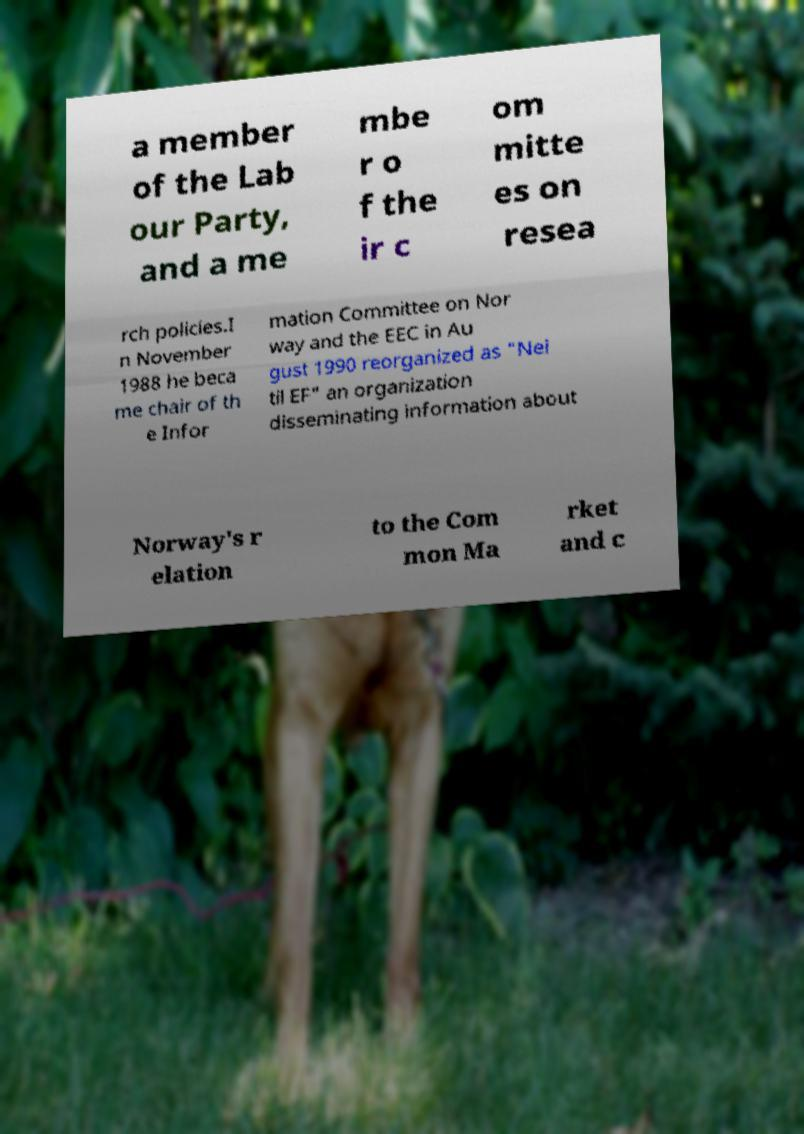There's text embedded in this image that I need extracted. Can you transcribe it verbatim? a member of the Lab our Party, and a me mbe r o f the ir c om mitte es on resea rch policies.I n November 1988 he beca me chair of th e Infor mation Committee on Nor way and the EEC in Au gust 1990 reorganized as "Nei til EF" an organization disseminating information about Norway's r elation to the Com mon Ma rket and c 